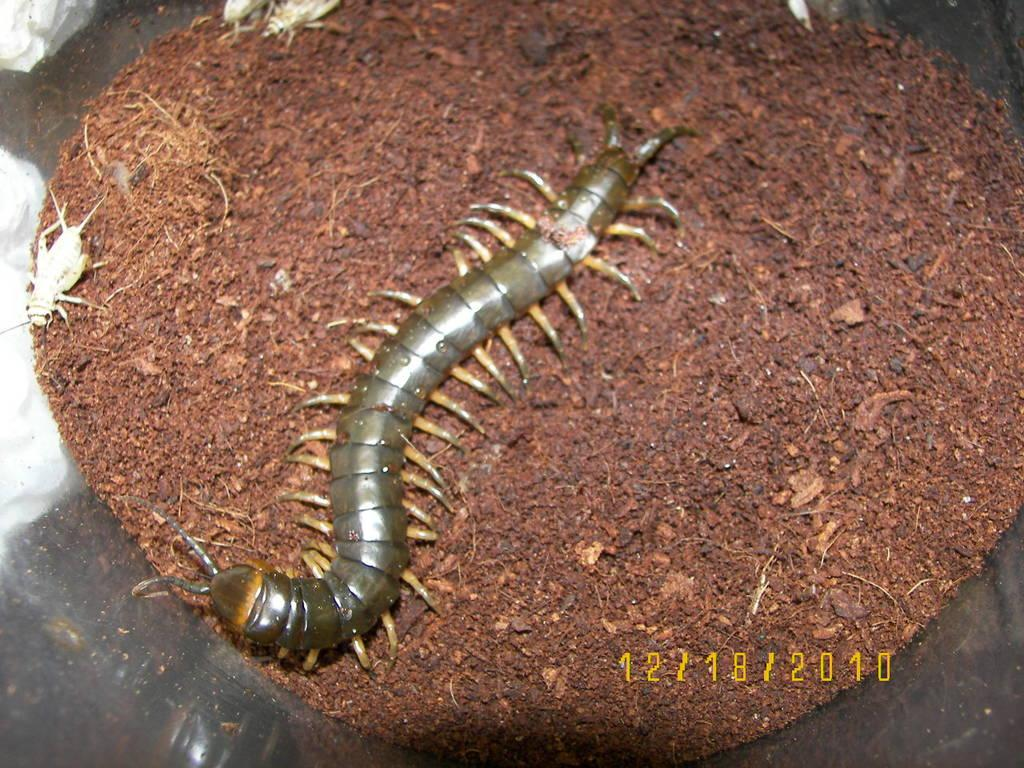What type of creatures can be seen in the image? There are insects and a millipede in the image. Where are the insects and millipede located? They are on the soil in the image. What is the soil contained within? The soil is contained within an object. Is there any additional information about the image itself? Yes, there is a watermark in the bottom right side of the image. Can you tell me which vein the insects are using to travel in the image? There are no veins present in the image, as it features insects and a millipede on soil. What type of humor can be seen in the image? There is no humor depicted in the image; it shows insects and a millipede on soil. 